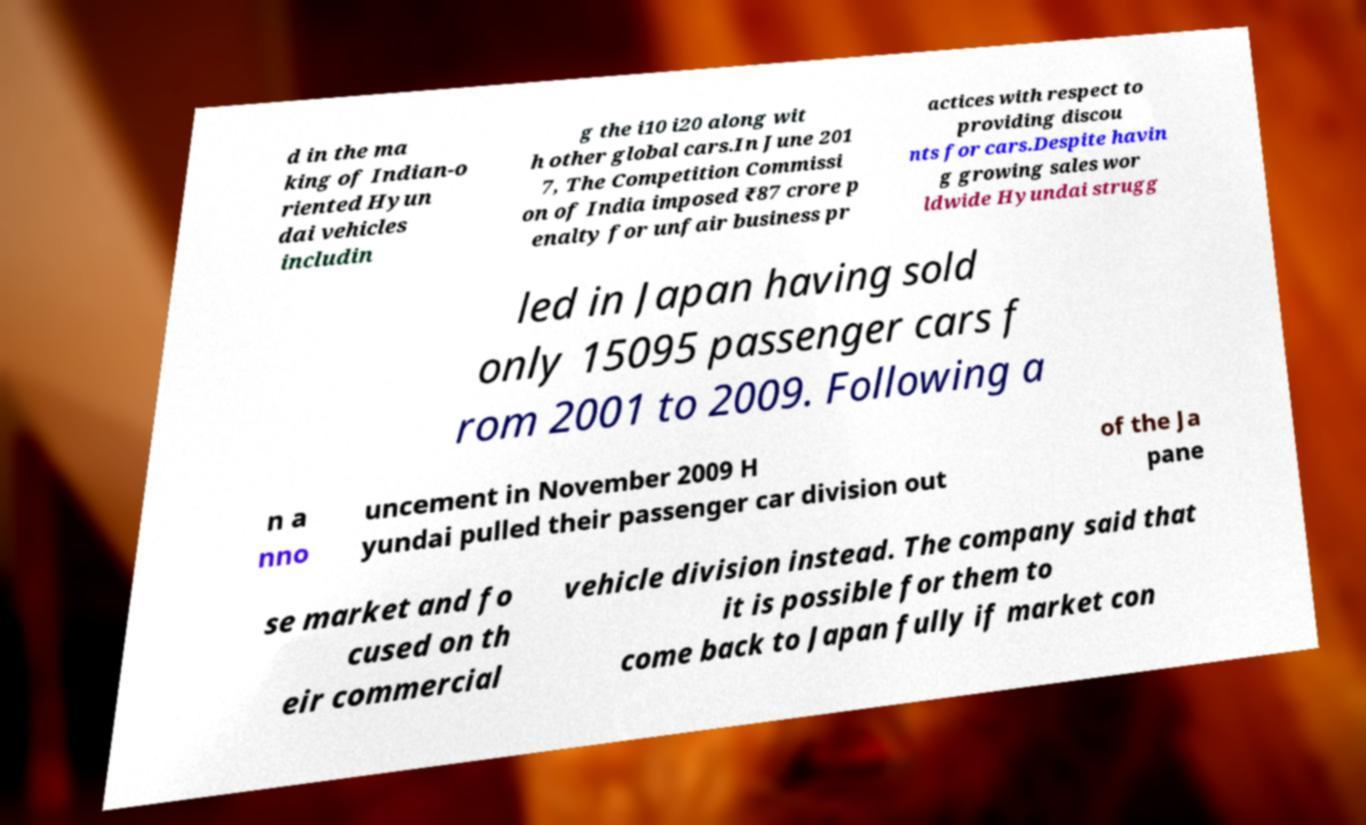What messages or text are displayed in this image? I need them in a readable, typed format. d in the ma king of Indian-o riented Hyun dai vehicles includin g the i10 i20 along wit h other global cars.In June 201 7, The Competition Commissi on of India imposed ₹87 crore p enalty for unfair business pr actices with respect to providing discou nts for cars.Despite havin g growing sales wor ldwide Hyundai strugg led in Japan having sold only 15095 passenger cars f rom 2001 to 2009. Following a n a nno uncement in November 2009 H yundai pulled their passenger car division out of the Ja pane se market and fo cused on th eir commercial vehicle division instead. The company said that it is possible for them to come back to Japan fully if market con 